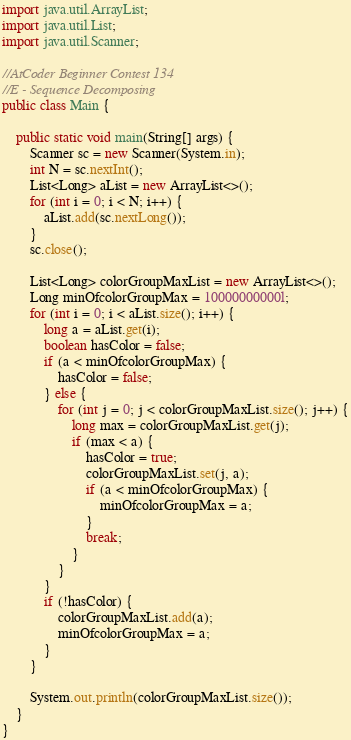Convert code to text. <code><loc_0><loc_0><loc_500><loc_500><_Java_>import java.util.ArrayList;
import java.util.List;
import java.util.Scanner;

//AtCoder Beginner Contest 134
//E - Sequence Decomposing
public class Main {

	public static void main(String[] args) {
		Scanner sc = new Scanner(System.in);
		int N = sc.nextInt();
		List<Long> aList = new ArrayList<>();
		for (int i = 0; i < N; i++) {
			aList.add(sc.nextLong());
		}
		sc.close();

		List<Long> colorGroupMaxList = new ArrayList<>();
		Long minOfcolorGroupMax = 10000000000l;
		for (int i = 0; i < aList.size(); i++) {
			long a = aList.get(i);
			boolean hasColor = false;
			if (a < minOfcolorGroupMax) {
				hasColor = false;
			} else {
				for (int j = 0; j < colorGroupMaxList.size(); j++) {
					long max = colorGroupMaxList.get(j);
					if (max < a) {
						hasColor = true;
						colorGroupMaxList.set(j, a);
						if (a < minOfcolorGroupMax) {
							minOfcolorGroupMax = a;
						}
						break;
					}
				}
			}
			if (!hasColor) {
				colorGroupMaxList.add(a);
				minOfcolorGroupMax = a;
			}
		}

		System.out.println(colorGroupMaxList.size());
	}
}
</code> 